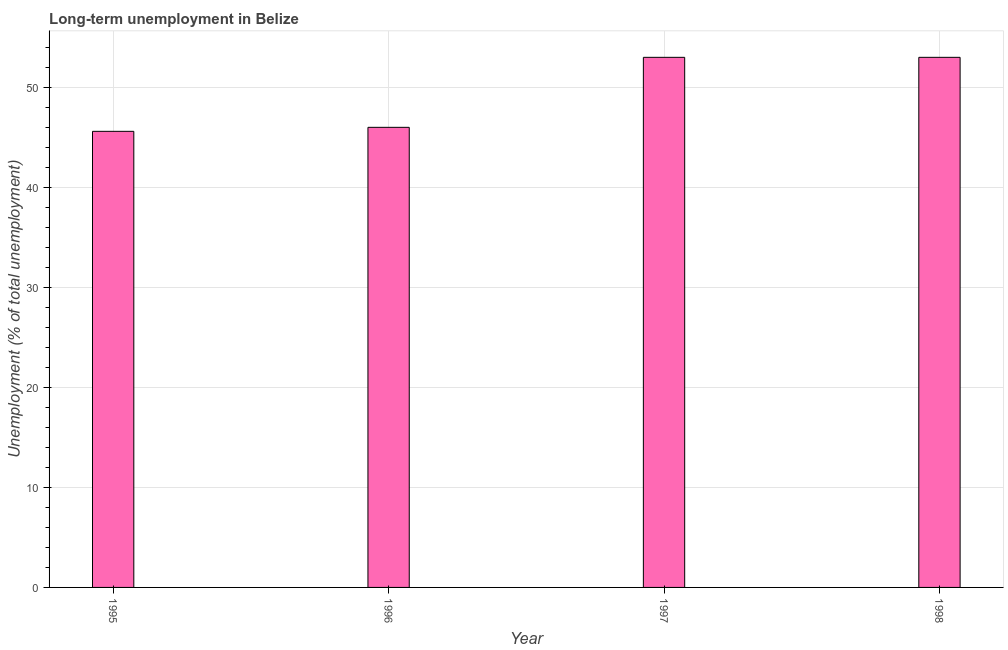What is the title of the graph?
Provide a short and direct response. Long-term unemployment in Belize. What is the label or title of the Y-axis?
Provide a short and direct response. Unemployment (% of total unemployment). What is the long-term unemployment in 1997?
Make the answer very short. 53. Across all years, what is the maximum long-term unemployment?
Ensure brevity in your answer.  53. Across all years, what is the minimum long-term unemployment?
Offer a terse response. 45.6. In which year was the long-term unemployment maximum?
Give a very brief answer. 1997. What is the sum of the long-term unemployment?
Provide a succinct answer. 197.6. What is the difference between the long-term unemployment in 1995 and 1996?
Keep it short and to the point. -0.4. What is the average long-term unemployment per year?
Your answer should be very brief. 49.4. What is the median long-term unemployment?
Ensure brevity in your answer.  49.5. In how many years, is the long-term unemployment greater than 22 %?
Make the answer very short. 4. Do a majority of the years between 1997 and 1996 (inclusive) have long-term unemployment greater than 44 %?
Your answer should be very brief. No. What is the ratio of the long-term unemployment in 1996 to that in 1997?
Provide a short and direct response. 0.87. What is the difference between the highest and the second highest long-term unemployment?
Keep it short and to the point. 0. Is the sum of the long-term unemployment in 1995 and 1997 greater than the maximum long-term unemployment across all years?
Your answer should be compact. Yes. What is the difference between the highest and the lowest long-term unemployment?
Offer a very short reply. 7.4. In how many years, is the long-term unemployment greater than the average long-term unemployment taken over all years?
Ensure brevity in your answer.  2. Are all the bars in the graph horizontal?
Offer a terse response. No. How many years are there in the graph?
Give a very brief answer. 4. What is the difference between two consecutive major ticks on the Y-axis?
Your answer should be very brief. 10. Are the values on the major ticks of Y-axis written in scientific E-notation?
Your answer should be compact. No. What is the Unemployment (% of total unemployment) in 1995?
Keep it short and to the point. 45.6. What is the difference between the Unemployment (% of total unemployment) in 1995 and 1997?
Provide a short and direct response. -7.4. What is the difference between the Unemployment (% of total unemployment) in 1996 and 1997?
Give a very brief answer. -7. What is the difference between the Unemployment (% of total unemployment) in 1996 and 1998?
Your response must be concise. -7. What is the difference between the Unemployment (% of total unemployment) in 1997 and 1998?
Offer a terse response. 0. What is the ratio of the Unemployment (% of total unemployment) in 1995 to that in 1996?
Your answer should be compact. 0.99. What is the ratio of the Unemployment (% of total unemployment) in 1995 to that in 1997?
Offer a very short reply. 0.86. What is the ratio of the Unemployment (% of total unemployment) in 1995 to that in 1998?
Keep it short and to the point. 0.86. What is the ratio of the Unemployment (% of total unemployment) in 1996 to that in 1997?
Keep it short and to the point. 0.87. What is the ratio of the Unemployment (% of total unemployment) in 1996 to that in 1998?
Make the answer very short. 0.87. What is the ratio of the Unemployment (% of total unemployment) in 1997 to that in 1998?
Make the answer very short. 1. 